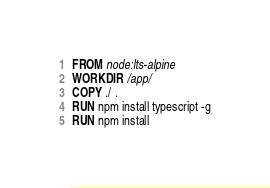Convert code to text. <code><loc_0><loc_0><loc_500><loc_500><_Dockerfile_>FROM node:lts-alpine
WORKDIR /app/
COPY ./ .
RUN npm install typescript -g
RUN npm install
</code> 